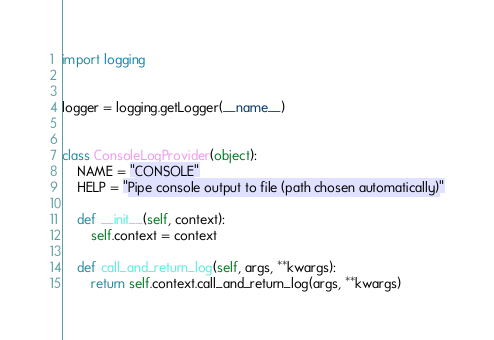<code> <loc_0><loc_0><loc_500><loc_500><_Python_>import logging


logger = logging.getLogger(__name__)


class ConsoleLogProvider(object):
    NAME = "CONSOLE"
    HELP = "Pipe console output to file (path chosen automatically)"

    def __init__(self, context):
        self.context = context

    def call_and_return_log(self, args, **kwargs):
        return self.context.call_and_return_log(args, **kwargs)
</code> 